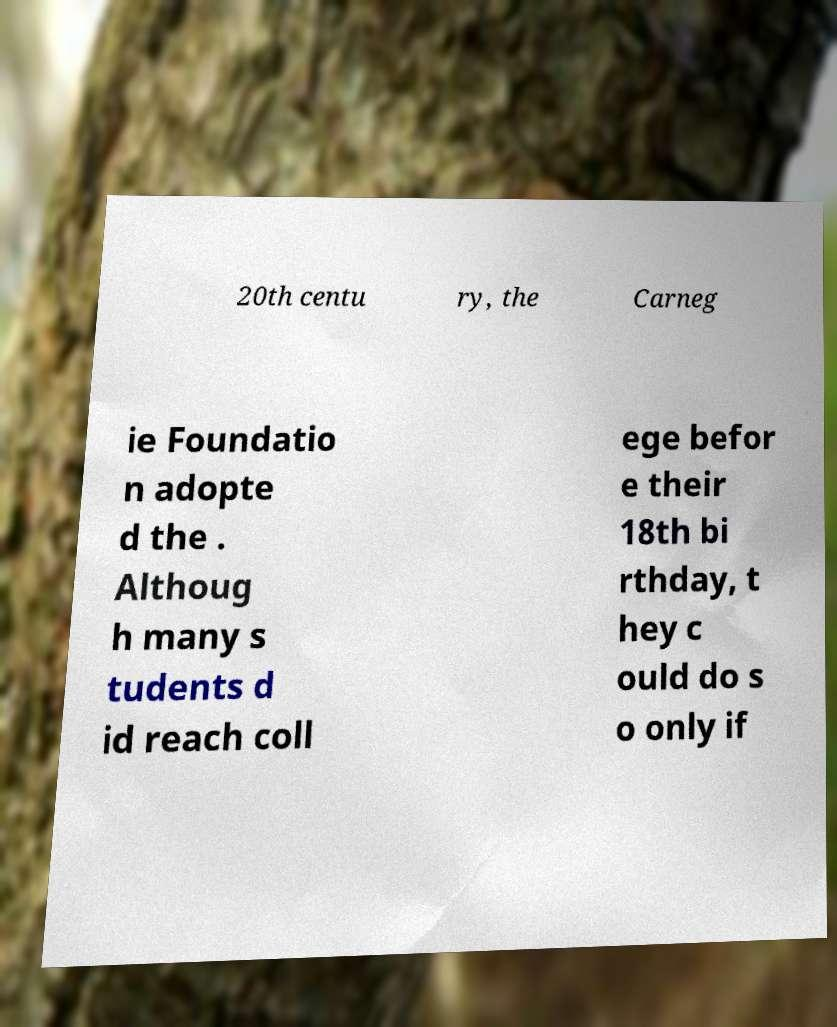What messages or text are displayed in this image? I need them in a readable, typed format. 20th centu ry, the Carneg ie Foundatio n adopte d the . Althoug h many s tudents d id reach coll ege befor e their 18th bi rthday, t hey c ould do s o only if 